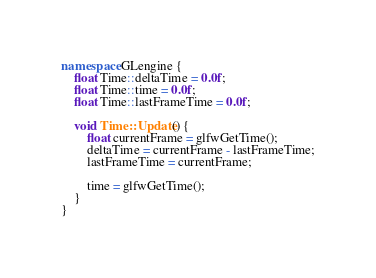Convert code to text. <code><loc_0><loc_0><loc_500><loc_500><_C++_>namespace GLengine {
    float Time::deltaTime = 0.0f;
    float Time::time = 0.0f;
    float Time::lastFrameTime = 0.0f;

    void Time::Update() {
        float currentFrame = glfwGetTime();
        deltaTime = currentFrame - lastFrameTime;
        lastFrameTime = currentFrame;

        time = glfwGetTime();
    }
}</code> 